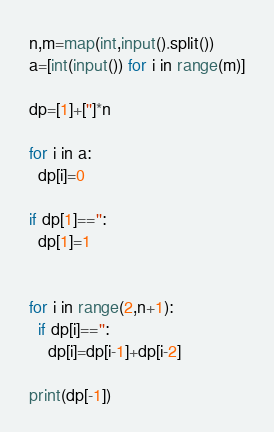Convert code to text. <code><loc_0><loc_0><loc_500><loc_500><_Python_>n,m=map(int,input().split())
a=[int(input()) for i in range(m)]

dp=[1]+['']*n

for i in a:
  dp[i]=0

if dp[1]=='':
  dp[1]=1
  

for i in range(2,n+1):
  if dp[i]=='':
    dp[i]=dp[i-1]+dp[i-2]

print(dp[-1])
</code> 